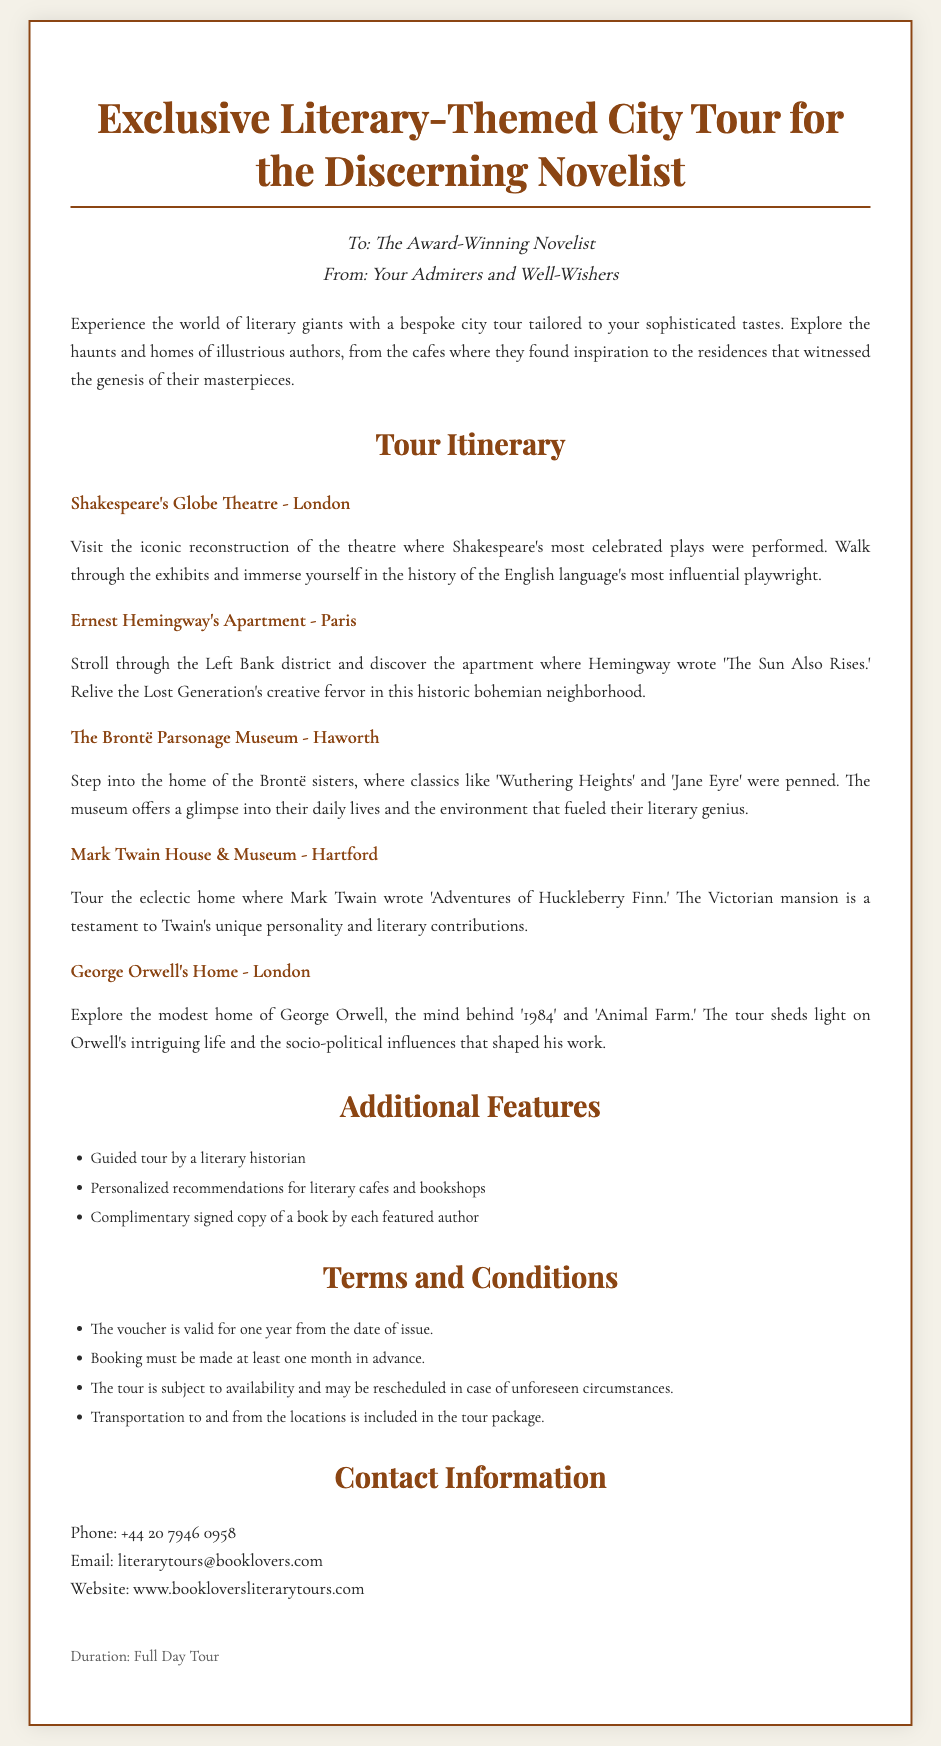What is the title of the voucher? The title of the voucher is clearly stated at the top of the document.
Answer: Exclusive Literary-Themed City Tour for the Discerning Novelist Who is the recipient of the voucher? The recipient is mentioned in the section addressing them directly.
Answer: The Award-Winning Novelist What is one of the locations included in the tour? Each location visited on the tour is outlined in the itinerary.
Answer: Shakespeare's Globe Theatre - London How long is the voucher valid? The terms and conditions specify its validity period.
Answer: One year What type of tour is this voucher for? The introduction indicates the nature of the experience offered.
Answer: Literary-themed city tour Who gives the gift? The document states who the gift is from in the recipient section.
Answer: Your Admirers and Well-Wishers What is included in the additional features of the tour? The additional features section lists the benefits included with the tour.
Answer: Guided tour by a literary historian How many locations are mentioned in the itinerary? The itinerary lays out the number of locations to visit.
Answer: Five What is required to book the tour? The terms and conditions mention a specific requirement for booking.
Answer: Booking must be made at least one month in advance 